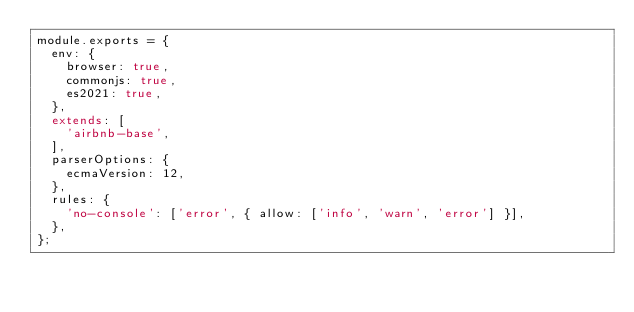Convert code to text. <code><loc_0><loc_0><loc_500><loc_500><_JavaScript_>module.exports = {
  env: {
    browser: true,
    commonjs: true,
    es2021: true,
  },
  extends: [
    'airbnb-base',
  ],
  parserOptions: {
    ecmaVersion: 12,
  },
  rules: {
    'no-console': ['error', { allow: ['info', 'warn', 'error'] }],
  },
};
</code> 